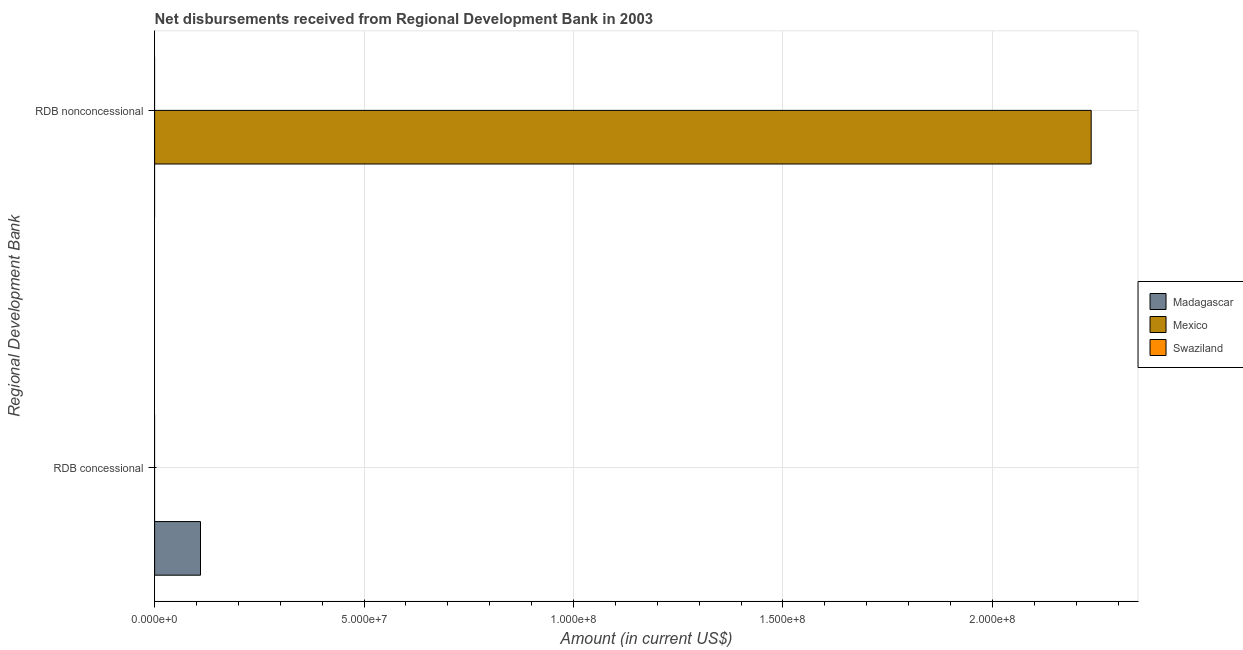How many different coloured bars are there?
Keep it short and to the point. 2. Are the number of bars per tick equal to the number of legend labels?
Your answer should be very brief. No. Are the number of bars on each tick of the Y-axis equal?
Your answer should be compact. Yes. How many bars are there on the 1st tick from the top?
Give a very brief answer. 1. What is the label of the 1st group of bars from the top?
Ensure brevity in your answer.  RDB nonconcessional. What is the net non concessional disbursements from rdb in Madagascar?
Give a very brief answer. 0. Across all countries, what is the maximum net concessional disbursements from rdb?
Offer a terse response. 1.10e+07. In which country was the net concessional disbursements from rdb maximum?
Offer a very short reply. Madagascar. What is the total net concessional disbursements from rdb in the graph?
Your answer should be compact. 1.10e+07. What is the difference between the net non concessional disbursements from rdb in Swaziland and the net concessional disbursements from rdb in Madagascar?
Keep it short and to the point. -1.10e+07. What is the average net non concessional disbursements from rdb per country?
Keep it short and to the point. 7.45e+07. In how many countries, is the net concessional disbursements from rdb greater than the average net concessional disbursements from rdb taken over all countries?
Ensure brevity in your answer.  1. Are all the bars in the graph horizontal?
Your response must be concise. Yes. How many countries are there in the graph?
Give a very brief answer. 3. What is the difference between two consecutive major ticks on the X-axis?
Your response must be concise. 5.00e+07. Are the values on the major ticks of X-axis written in scientific E-notation?
Your response must be concise. Yes. What is the title of the graph?
Provide a short and direct response. Net disbursements received from Regional Development Bank in 2003. What is the label or title of the Y-axis?
Ensure brevity in your answer.  Regional Development Bank. What is the Amount (in current US$) of Madagascar in RDB concessional?
Your answer should be very brief. 1.10e+07. What is the Amount (in current US$) in Swaziland in RDB concessional?
Keep it short and to the point. 0. What is the Amount (in current US$) of Mexico in RDB nonconcessional?
Provide a succinct answer. 2.24e+08. What is the Amount (in current US$) of Swaziland in RDB nonconcessional?
Provide a succinct answer. 0. Across all Regional Development Bank, what is the maximum Amount (in current US$) of Madagascar?
Offer a terse response. 1.10e+07. Across all Regional Development Bank, what is the maximum Amount (in current US$) in Mexico?
Give a very brief answer. 2.24e+08. Across all Regional Development Bank, what is the minimum Amount (in current US$) of Madagascar?
Offer a very short reply. 0. What is the total Amount (in current US$) of Madagascar in the graph?
Your answer should be very brief. 1.10e+07. What is the total Amount (in current US$) in Mexico in the graph?
Your answer should be very brief. 2.24e+08. What is the total Amount (in current US$) of Swaziland in the graph?
Your answer should be very brief. 0. What is the difference between the Amount (in current US$) in Madagascar in RDB concessional and the Amount (in current US$) in Mexico in RDB nonconcessional?
Make the answer very short. -2.13e+08. What is the average Amount (in current US$) in Madagascar per Regional Development Bank?
Your response must be concise. 5.48e+06. What is the average Amount (in current US$) in Mexico per Regional Development Bank?
Your response must be concise. 1.12e+08. What is the average Amount (in current US$) of Swaziland per Regional Development Bank?
Make the answer very short. 0. What is the difference between the highest and the lowest Amount (in current US$) in Madagascar?
Provide a succinct answer. 1.10e+07. What is the difference between the highest and the lowest Amount (in current US$) in Mexico?
Provide a short and direct response. 2.24e+08. 